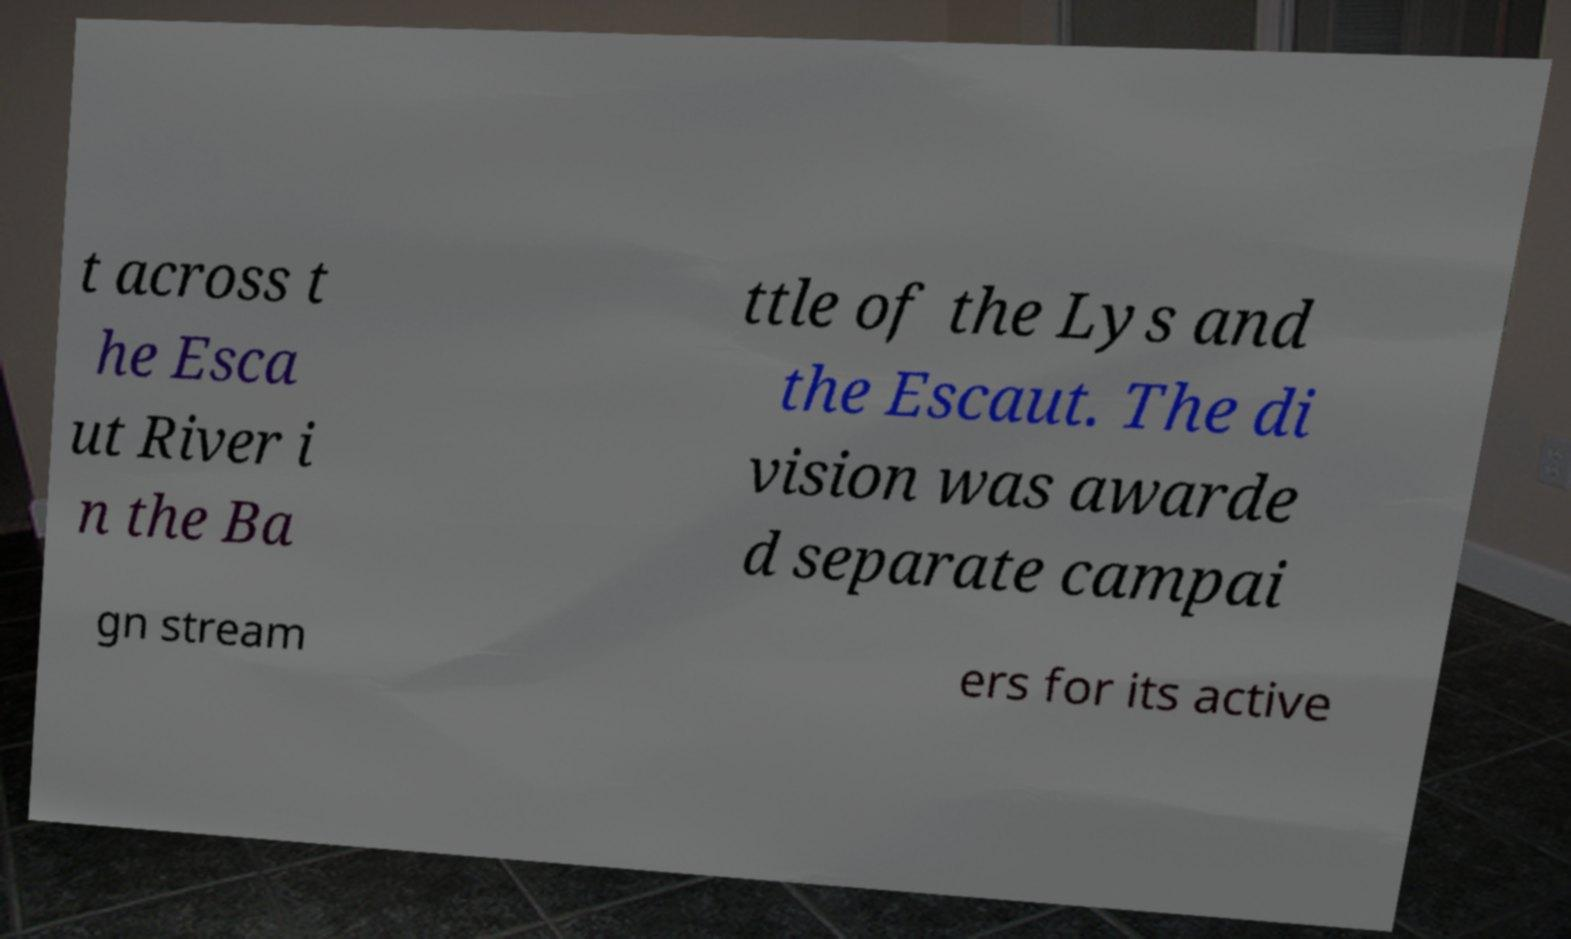I need the written content from this picture converted into text. Can you do that? t across t he Esca ut River i n the Ba ttle of the Lys and the Escaut. The di vision was awarde d separate campai gn stream ers for its active 